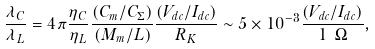Convert formula to latex. <formula><loc_0><loc_0><loc_500><loc_500>\frac { \lambda _ { C } } { \lambda _ { L } } = 4 \pi \frac { \eta _ { C } } { \eta _ { L } } \frac { ( C _ { m } / C _ { \Sigma } ) } { ( M _ { m } / L ) } \frac { ( V _ { d c } / I _ { d c } ) } { R _ { K } } \sim 5 \times 1 0 ^ { - 3 } \frac { ( V _ { d c } / I _ { d c } ) } { 1 \ \Omega } ,</formula> 